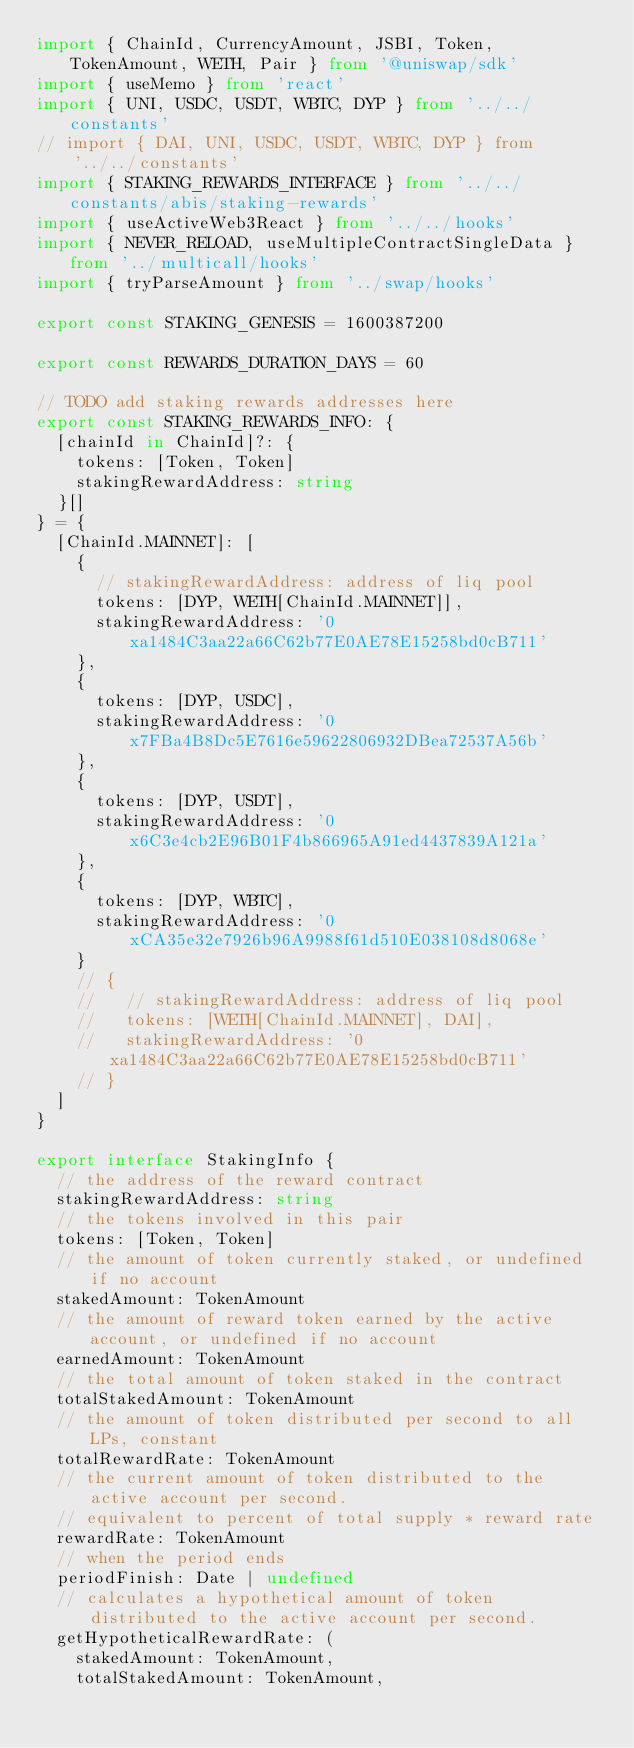Convert code to text. <code><loc_0><loc_0><loc_500><loc_500><_TypeScript_>import { ChainId, CurrencyAmount, JSBI, Token, TokenAmount, WETH, Pair } from '@uniswap/sdk'
import { useMemo } from 'react'
import { UNI, USDC, USDT, WBTC, DYP } from '../../constants'
// import { DAI, UNI, USDC, USDT, WBTC, DYP } from '../../constants'
import { STAKING_REWARDS_INTERFACE } from '../../constants/abis/staking-rewards'
import { useActiveWeb3React } from '../../hooks'
import { NEVER_RELOAD, useMultipleContractSingleData } from '../multicall/hooks'
import { tryParseAmount } from '../swap/hooks'

export const STAKING_GENESIS = 1600387200

export const REWARDS_DURATION_DAYS = 60

// TODO add staking rewards addresses here
export const STAKING_REWARDS_INFO: {
  [chainId in ChainId]?: {
    tokens: [Token, Token]
    stakingRewardAddress: string
  }[]
} = {
  [ChainId.MAINNET]: [
    {
      // stakingRewardAddress: address of liq pool
      tokens: [DYP, WETH[ChainId.MAINNET]],
      stakingRewardAddress: '0xa1484C3aa22a66C62b77E0AE78E15258bd0cB711'
    },
    {
      tokens: [DYP, USDC],
      stakingRewardAddress: '0x7FBa4B8Dc5E7616e59622806932DBea72537A56b'
    },
    {
      tokens: [DYP, USDT],
      stakingRewardAddress: '0x6C3e4cb2E96B01F4b866965A91ed4437839A121a'
    },
    {
      tokens: [DYP, WBTC],
      stakingRewardAddress: '0xCA35e32e7926b96A9988f61d510E038108d8068e'
    }
    // {
    //   // stakingRewardAddress: address of liq pool
    //   tokens: [WETH[ChainId.MAINNET], DAI],
    //   stakingRewardAddress: '0xa1484C3aa22a66C62b77E0AE78E15258bd0cB711'
    // }
  ]
}

export interface StakingInfo {
  // the address of the reward contract
  stakingRewardAddress: string
  // the tokens involved in this pair
  tokens: [Token, Token]
  // the amount of token currently staked, or undefined if no account
  stakedAmount: TokenAmount
  // the amount of reward token earned by the active account, or undefined if no account
  earnedAmount: TokenAmount
  // the total amount of token staked in the contract
  totalStakedAmount: TokenAmount
  // the amount of token distributed per second to all LPs, constant
  totalRewardRate: TokenAmount
  // the current amount of token distributed to the active account per second.
  // equivalent to percent of total supply * reward rate
  rewardRate: TokenAmount
  // when the period ends
  periodFinish: Date | undefined
  // calculates a hypothetical amount of token distributed to the active account per second.
  getHypotheticalRewardRate: (
    stakedAmount: TokenAmount,
    totalStakedAmount: TokenAmount,</code> 